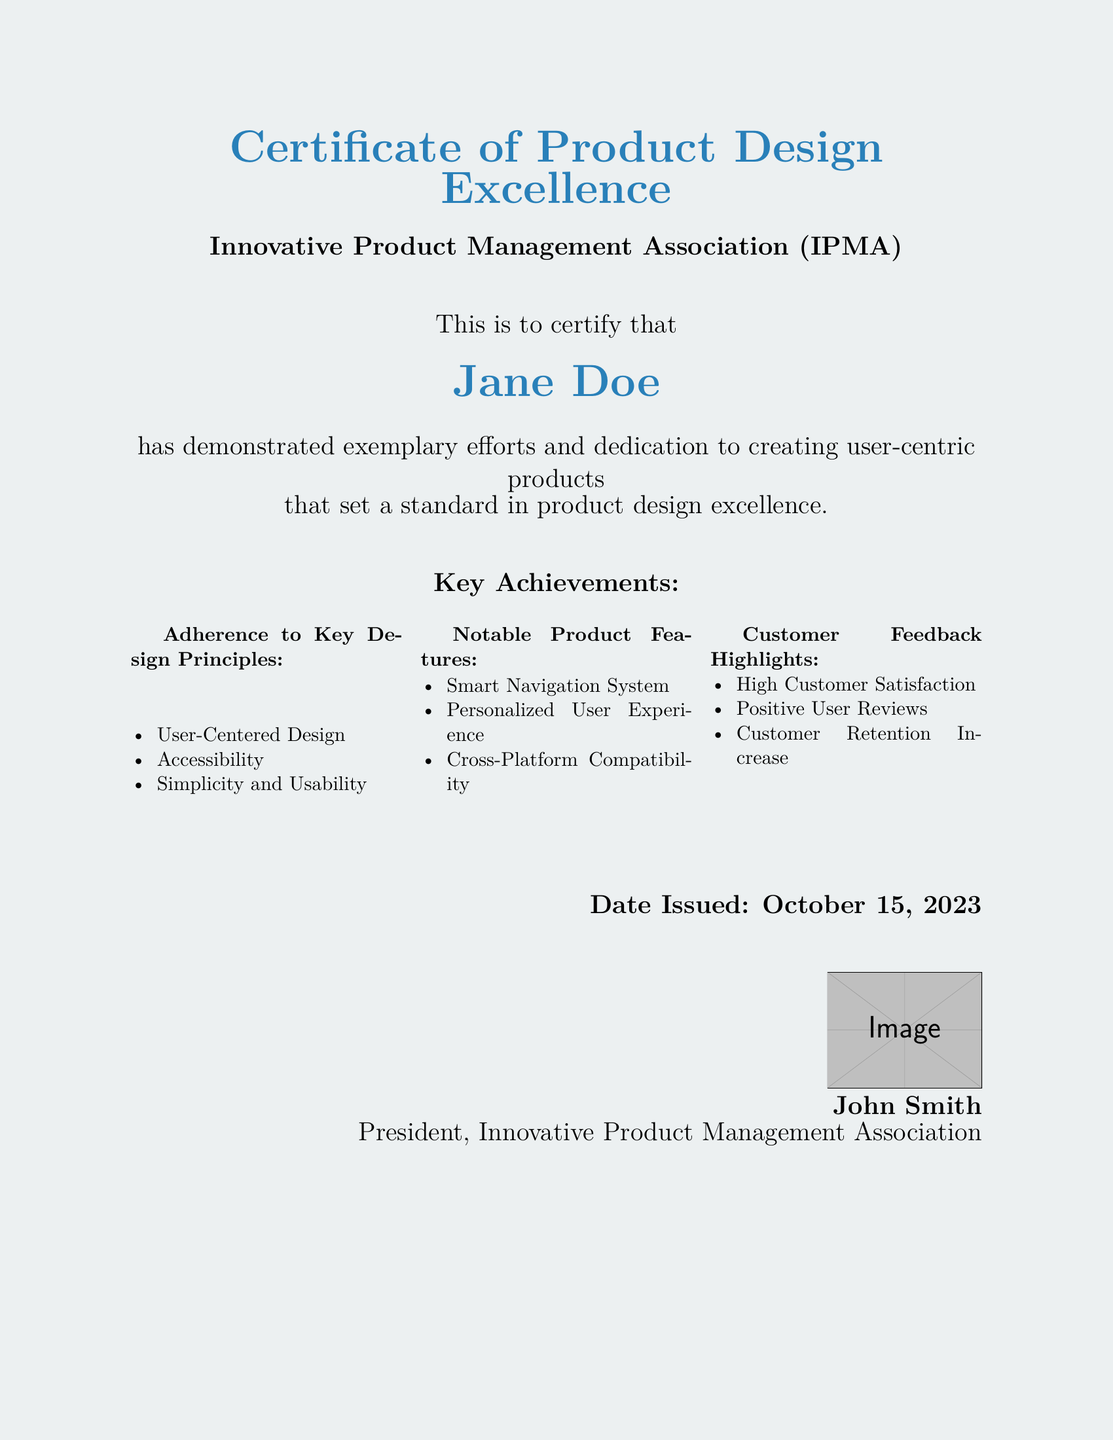What is the title of the certificate? The title of the certificate is prominently displayed at the top of the document as a recognition of design excellence.
Answer: Certificate of Product Design Excellence Who issued the certificate? The issuer of the certificate is mentioned below the title, crediting the relevant association.
Answer: Innovative Product Management Association What is the name of the recipient? The recipient's name is highlighted in a larger font size for recognition purposes.
Answer: Jane Doe What is the date issued on the certificate? The date is located at the bottom right, indicating when the certificate was issued.
Answer: October 15, 2023 What key design principle emphasizes user perspective? This principle is part of three outlined in the achievements section of the certificate.
Answer: User-Centered Design What notable feature allows intuitive navigation? This feature is specified in the achievements section, highlighting its importance for users.
Answer: Smart Navigation System What is a highlight from customer feedback? A key feedback point is mentioned as a measure of the product's success in the market.
Answer: High Customer Satisfaction What position does John Smith hold? His designation is found next to his signature at the bottom of the certificate.
Answer: President What was one notable outcome from customer interactions? This outcome reflects the effectiveness of the product based on customer engagement.
Answer: Customer Retention Increase 